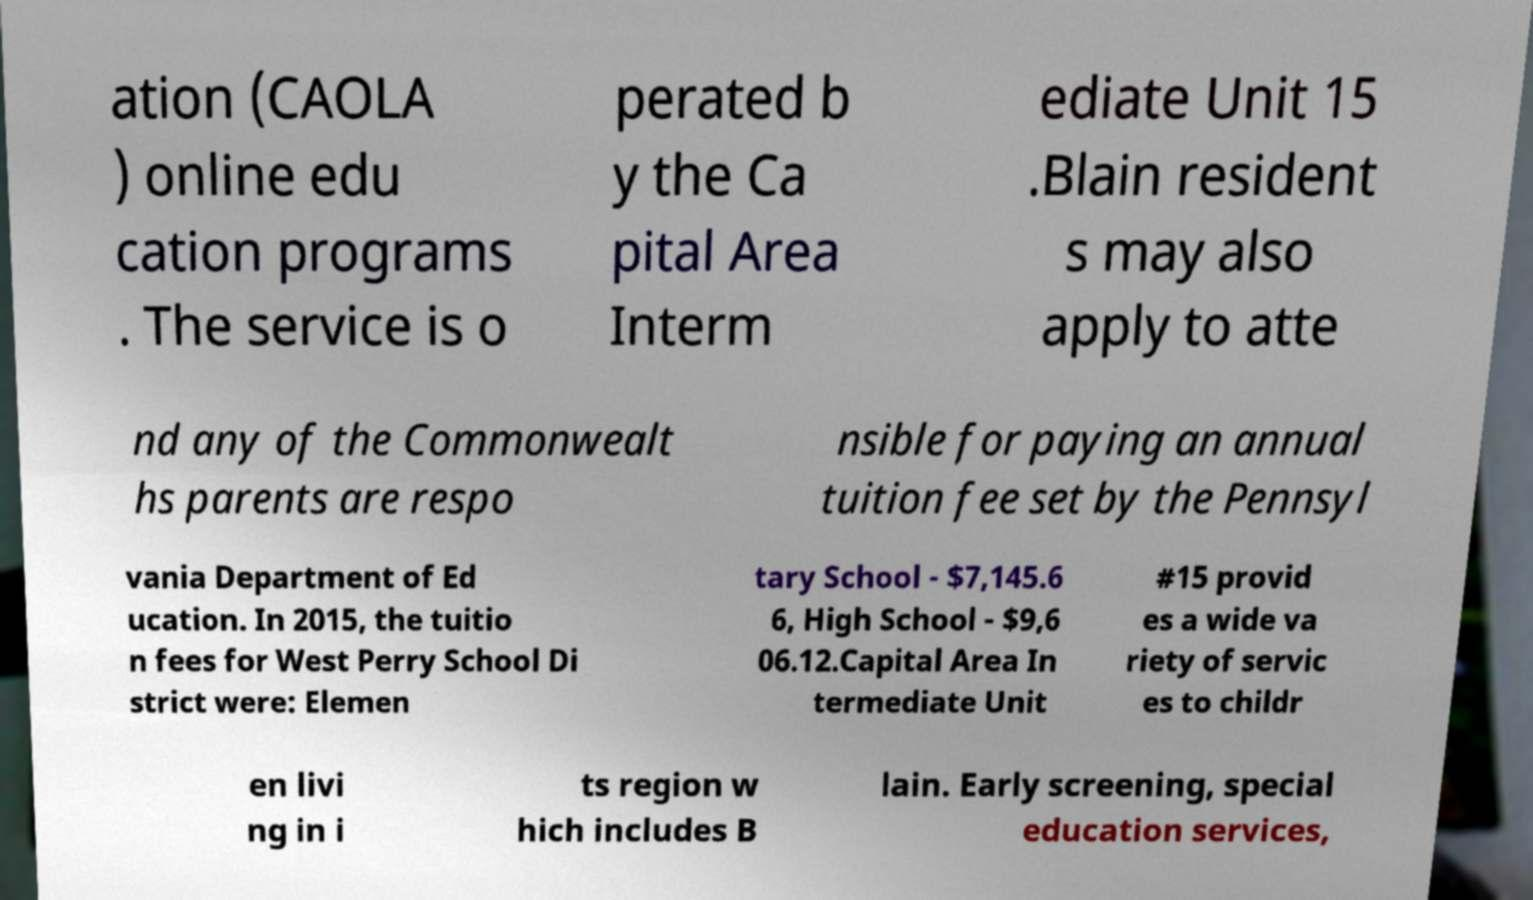What messages or text are displayed in this image? I need them in a readable, typed format. ation (CAOLA ) online edu cation programs . The service is o perated b y the Ca pital Area Interm ediate Unit 15 .Blain resident s may also apply to atte nd any of the Commonwealt hs parents are respo nsible for paying an annual tuition fee set by the Pennsyl vania Department of Ed ucation. In 2015, the tuitio n fees for West Perry School Di strict were: Elemen tary School - $7,145.6 6, High School - $9,6 06.12.Capital Area In termediate Unit #15 provid es a wide va riety of servic es to childr en livi ng in i ts region w hich includes B lain. Early screening, special education services, 